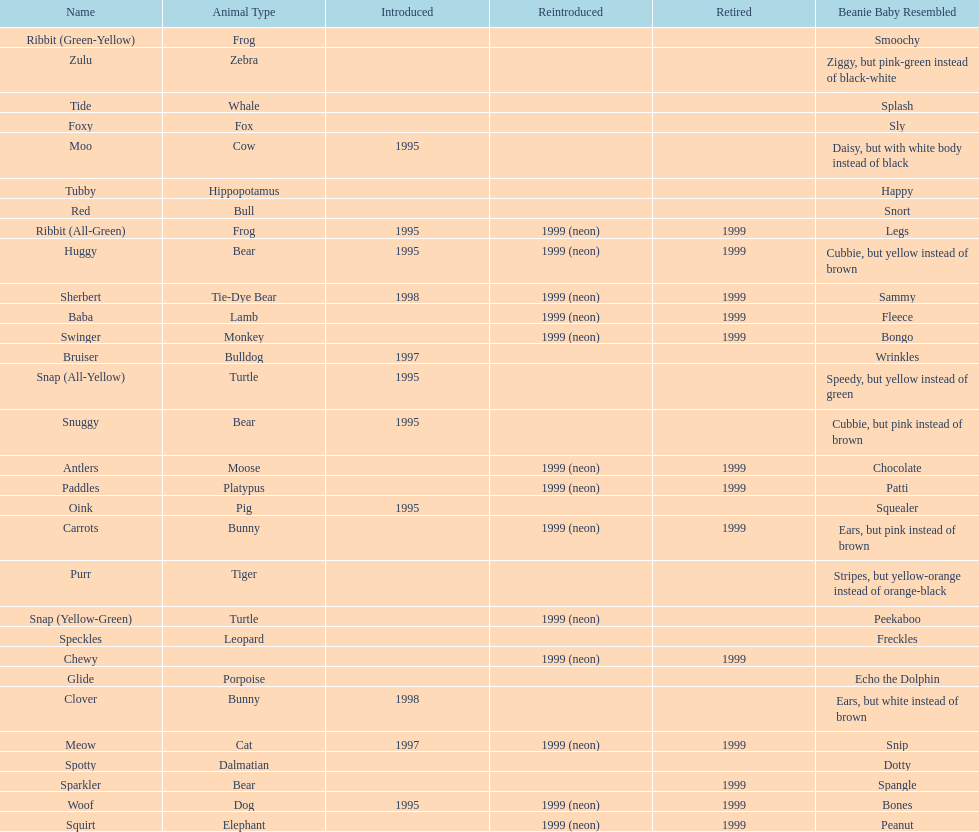How long was woof the dog sold before it was retired? 4 years. 